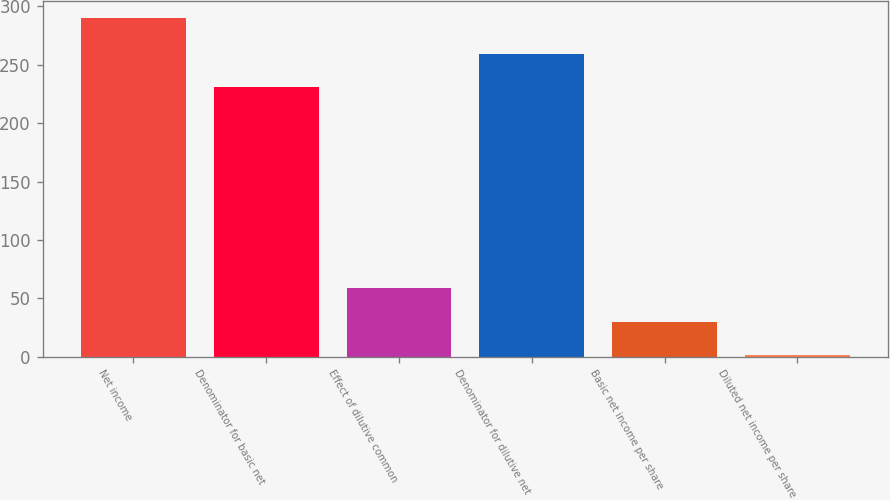Convert chart. <chart><loc_0><loc_0><loc_500><loc_500><bar_chart><fcel>Net income<fcel>Denominator for basic net<fcel>Effect of dilutive common<fcel>Denominator for dilutive net<fcel>Basic net income per share<fcel>Diluted net income per share<nl><fcel>289.7<fcel>230.7<fcel>58.89<fcel>259.55<fcel>30.04<fcel>1.19<nl></chart> 